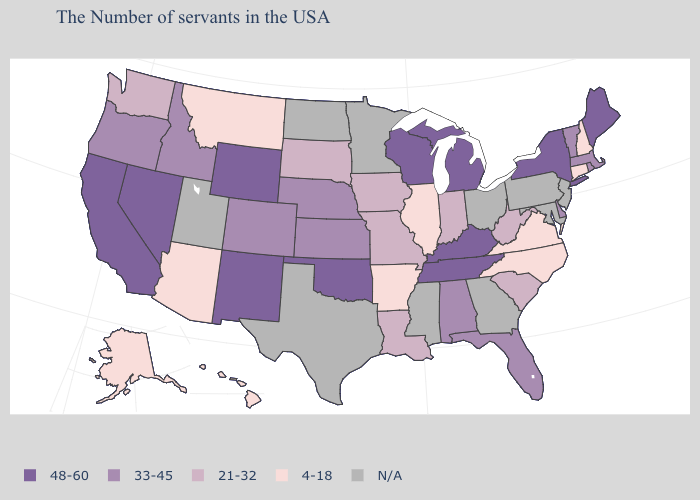Does Illinois have the highest value in the USA?
Short answer required. No. Name the states that have a value in the range N/A?
Quick response, please. New Jersey, Maryland, Pennsylvania, Ohio, Georgia, Mississippi, Minnesota, Texas, North Dakota, Utah. What is the value of Connecticut?
Keep it brief. 4-18. What is the lowest value in the USA?
Keep it brief. 4-18. Does the map have missing data?
Concise answer only. Yes. What is the highest value in the USA?
Keep it brief. 48-60. Name the states that have a value in the range N/A?
Write a very short answer. New Jersey, Maryland, Pennsylvania, Ohio, Georgia, Mississippi, Minnesota, Texas, North Dakota, Utah. Name the states that have a value in the range 4-18?
Quick response, please. New Hampshire, Connecticut, Virginia, North Carolina, Illinois, Arkansas, Montana, Arizona, Alaska, Hawaii. Does New Mexico have the highest value in the West?
Keep it brief. Yes. What is the lowest value in states that border Tennessee?
Quick response, please. 4-18. What is the value of Wisconsin?
Answer briefly. 48-60. What is the value of Iowa?
Concise answer only. 21-32. Which states have the highest value in the USA?
Short answer required. Maine, New York, Michigan, Kentucky, Tennessee, Wisconsin, Oklahoma, Wyoming, New Mexico, Nevada, California. What is the value of Maryland?
Quick response, please. N/A. Among the states that border Virginia , does North Carolina have the lowest value?
Give a very brief answer. Yes. 